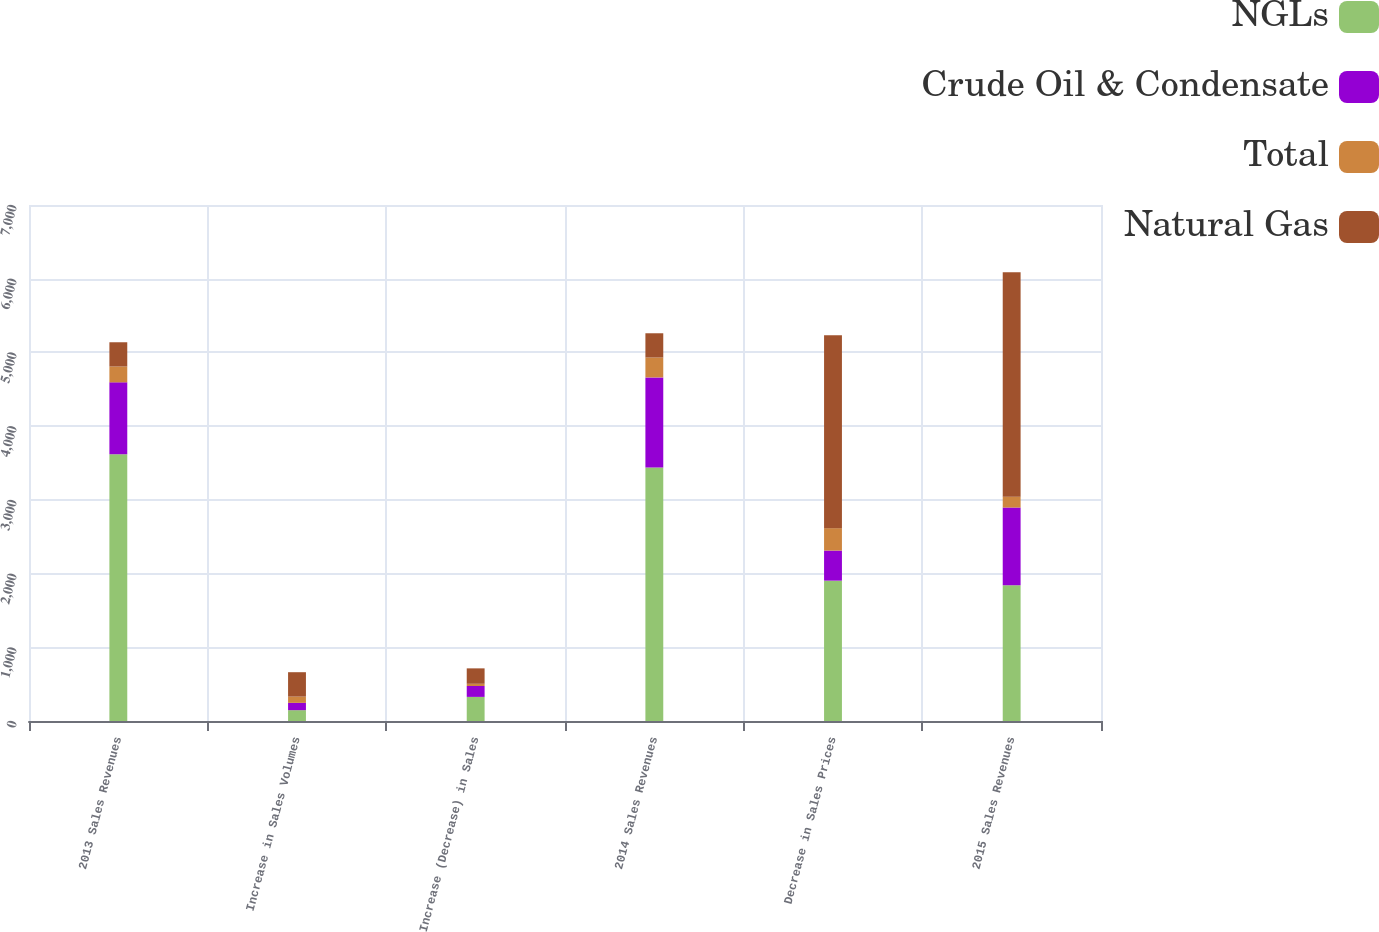Convert chart. <chart><loc_0><loc_0><loc_500><loc_500><stacked_bar_chart><ecel><fcel>2013 Sales Revenues<fcel>Increase in Sales Volumes<fcel>Increase (Decrease) in Sales<fcel>2014 Sales Revenues<fcel>Decrease in Sales Prices<fcel>2015 Sales Revenues<nl><fcel>NGLs<fcel>3618<fcel>147<fcel>327<fcel>3438<fcel>1904<fcel>1840<nl><fcel>Crude Oil & Condensate<fcel>976<fcel>99<fcel>148<fcel>1223<fcel>408<fcel>1056<nl><fcel>Total<fcel>215<fcel>85<fcel>30<fcel>270<fcel>304<fcel>147<nl><fcel>Natural Gas<fcel>329<fcel>331<fcel>209<fcel>329<fcel>2616<fcel>3043<nl></chart> 